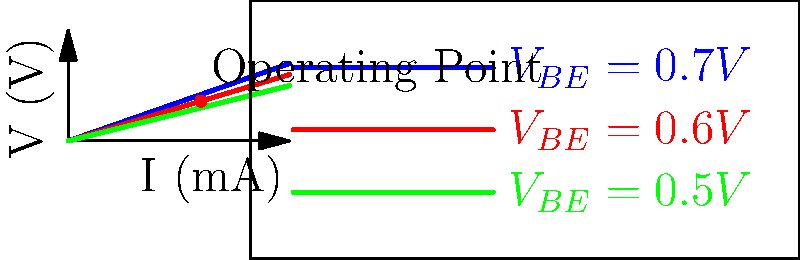Given the I-V characteristics of a transistor shown in the graph, what can you infer about the relationship between the base-emitter voltage ($V_{BE}$) and the collector current ($I_C$)? How would this knowledge be useful in transfer learning applications for modeling transistor behavior? To understand the relationship between $V_{BE}$ and $I_C$, let's analyze the graph step by step:

1. Observe the three curves: Each curve represents a different $V_{BE}$ value (0.7V, 0.6V, and 0.5V).

2. Curve steepness: As $V_{BE}$ increases, the curves become steeper, indicating a higher rate of change in $I_C$ with respect to the collector-emitter voltage ($V_{CE}$).

3. Current levels: For any given $V_{CE}$, a higher $V_{BE}$ results in a higher $I_C$. This shows a positive correlation between $V_{BE}$ and $I_C$.

4. Non-linear relationship: The curves are not straight lines, indicating a non-linear relationship between $V_{BE}$ and $I_C$.

5. Exponential behavior: The relationship between $V_{BE}$ and $I_C$ is approximately exponential, following the Ebers-Moll model: $I_C \approx I_S \cdot e^{\frac{V_{BE}}{V_T}}$, where $I_S$ is the saturation current and $V_T$ is the thermal voltage.

In transfer learning applications for modeling transistor behavior:

6. Feature extraction: The exponential relationship can be used as a key feature in machine learning models.

7. Model adaptation: Knowledge of this relationship can help in adapting models trained on one type of transistor to another with similar characteristics.

8. Data augmentation: Understanding this relationship allows for the generation of synthetic data points to augment limited real-world data.

9. Performance improvement: Incorporating this domain knowledge can lead to more accurate and efficient models, especially when dealing with limited training data.

10. Generalization: The understanding of this fundamental relationship can improve the model's ability to generalize across different transistor types and operating conditions.
Answer: $V_{BE}$ and $I_C$ have a positive, non-linear (approximately exponential) relationship. This knowledge enables feature extraction, model adaptation, data augmentation, and improved generalization in transfer learning for transistor behavior modeling. 